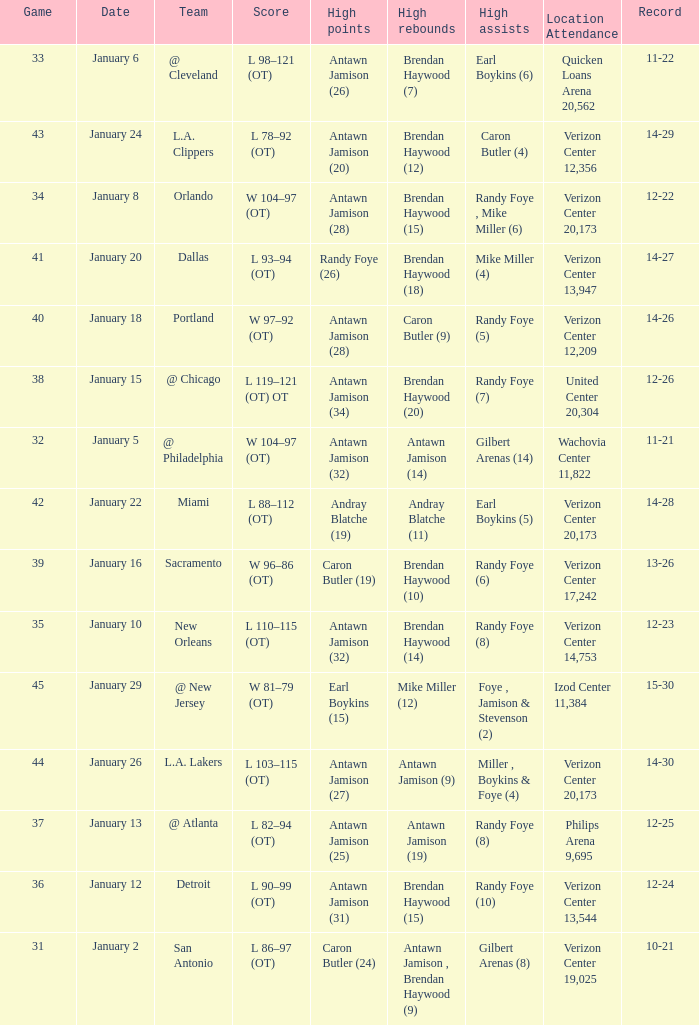Who had the highest points on January 2? Caron Butler (24). 